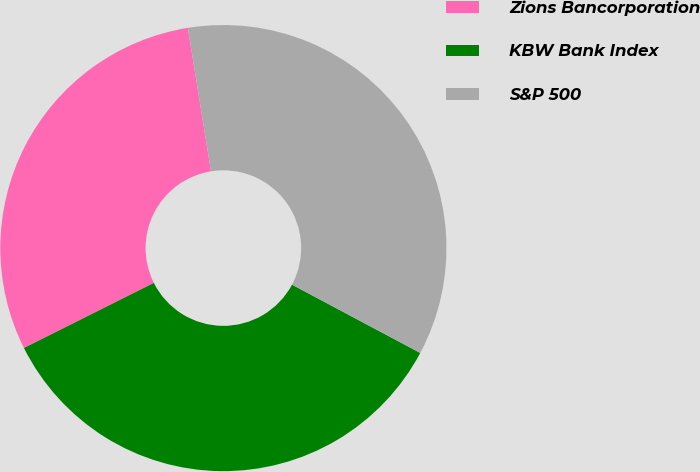Convert chart. <chart><loc_0><loc_0><loc_500><loc_500><pie_chart><fcel>Zions Bancorporation<fcel>KBW Bank Index<fcel>S&P 500<nl><fcel>29.85%<fcel>34.82%<fcel>35.34%<nl></chart> 